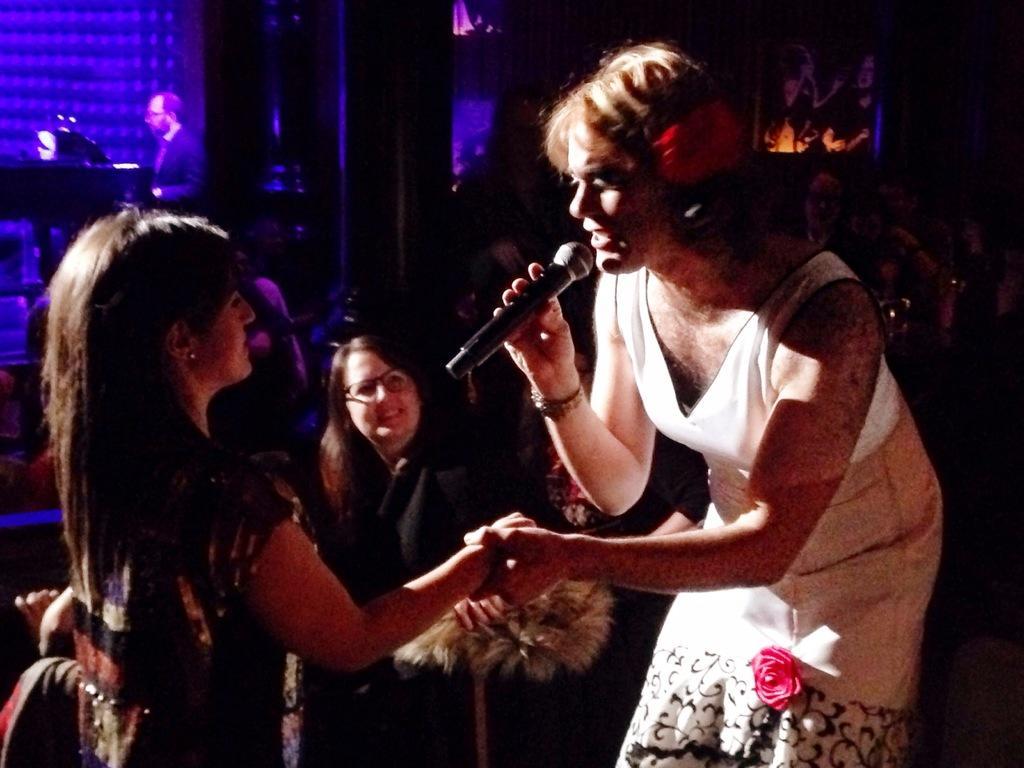Could you give a brief overview of what you see in this image? On the right side, there is a woman in white color t-shirt, holding a mic with one hand, speaking and holding a hand of the other woman who is in front of her. In the background, there are is a woman smiling and there is a person standing. And the background is dark in color. 